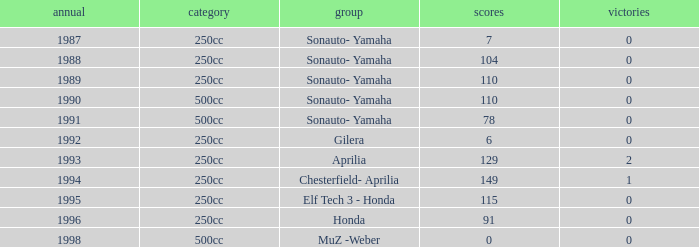What is the highest number of points the team with 0 wins had before 1992? 110.0. 